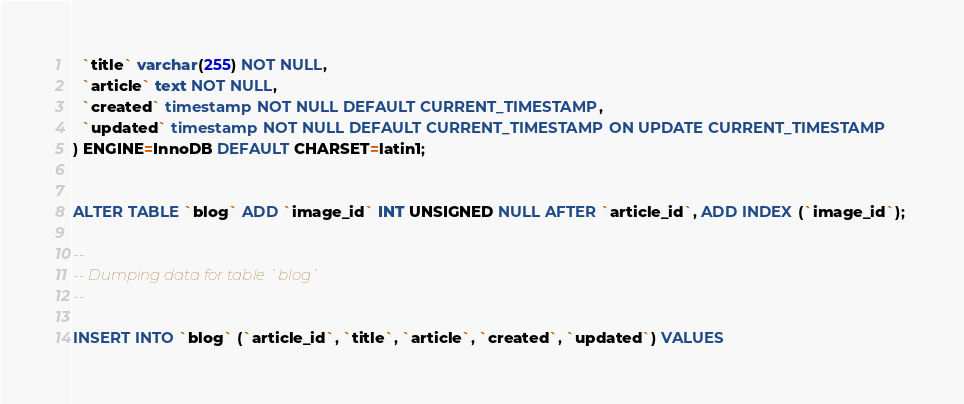<code> <loc_0><loc_0><loc_500><loc_500><_SQL_>  `title` varchar(255) NOT NULL,
  `article` text NOT NULL,
  `created` timestamp NOT NULL DEFAULT CURRENT_TIMESTAMP,
  `updated` timestamp NOT NULL DEFAULT CURRENT_TIMESTAMP ON UPDATE CURRENT_TIMESTAMP
) ENGINE=InnoDB DEFAULT CHARSET=latin1;


ALTER TABLE `blog` ADD `image_id` INT UNSIGNED NULL AFTER `article_id`, ADD INDEX (`image_id`); 

--
-- Dumping data for table `blog`
--

INSERT INTO `blog` (`article_id`, `title`, `article`, `created`, `updated`) VALUES</code> 